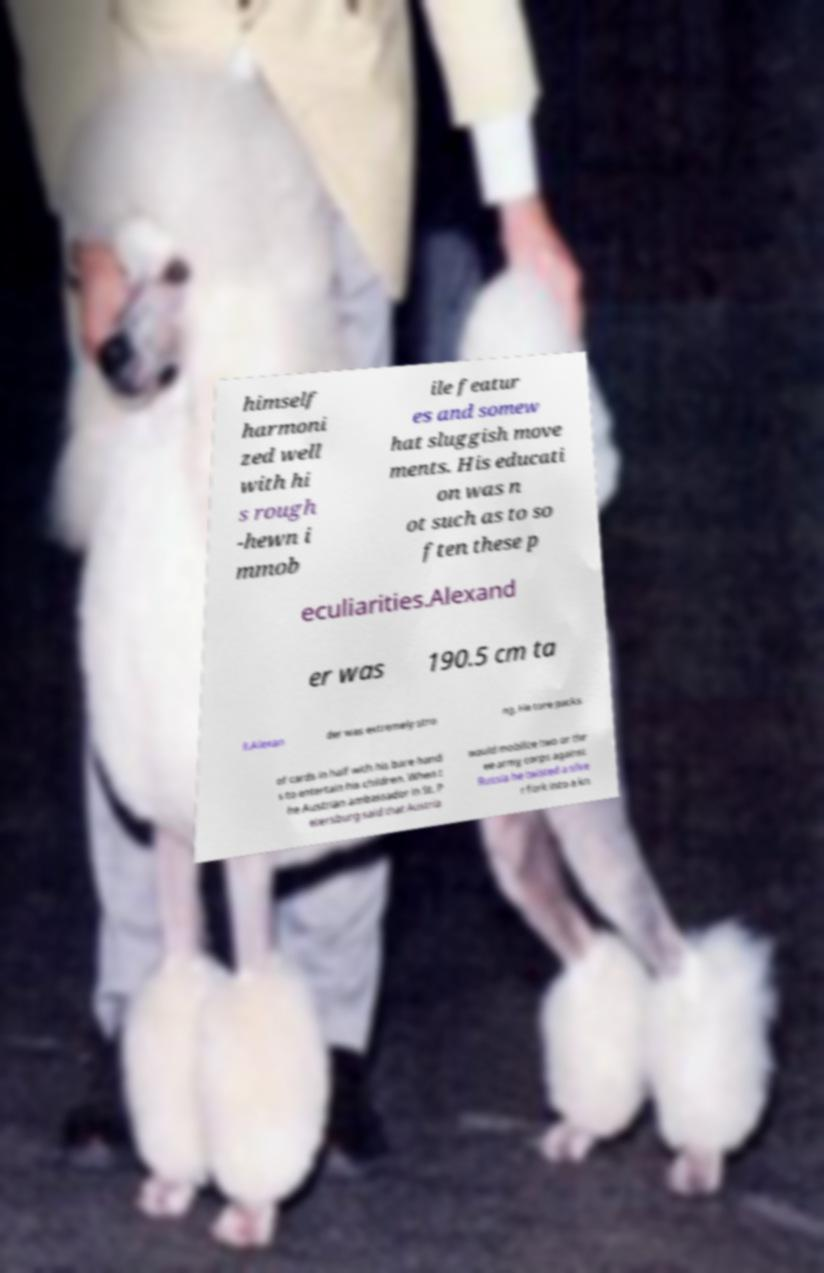Can you accurately transcribe the text from the provided image for me? himself harmoni zed well with hi s rough -hewn i mmob ile featur es and somew hat sluggish move ments. His educati on was n ot such as to so ften these p eculiarities.Alexand er was 190.5 cm ta ll.Alexan der was extremely stro ng. He tore packs of cards in half with his bare hand s to entertain his children. When t he Austrian ambassador in St. P etersburg said that Austria would mobilize two or thr ee army corps against Russia he twisted a silve r fork into a kn 